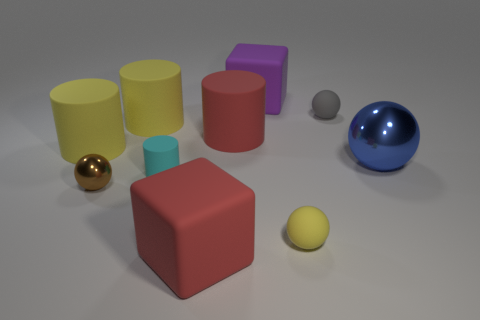Subtract all cylinders. How many objects are left? 6 Add 3 big blue metallic balls. How many big blue metallic balls are left? 4 Add 2 red cylinders. How many red cylinders exist? 3 Subtract 0 cyan blocks. How many objects are left? 10 Subtract all small rubber cylinders. Subtract all big blue metallic objects. How many objects are left? 8 